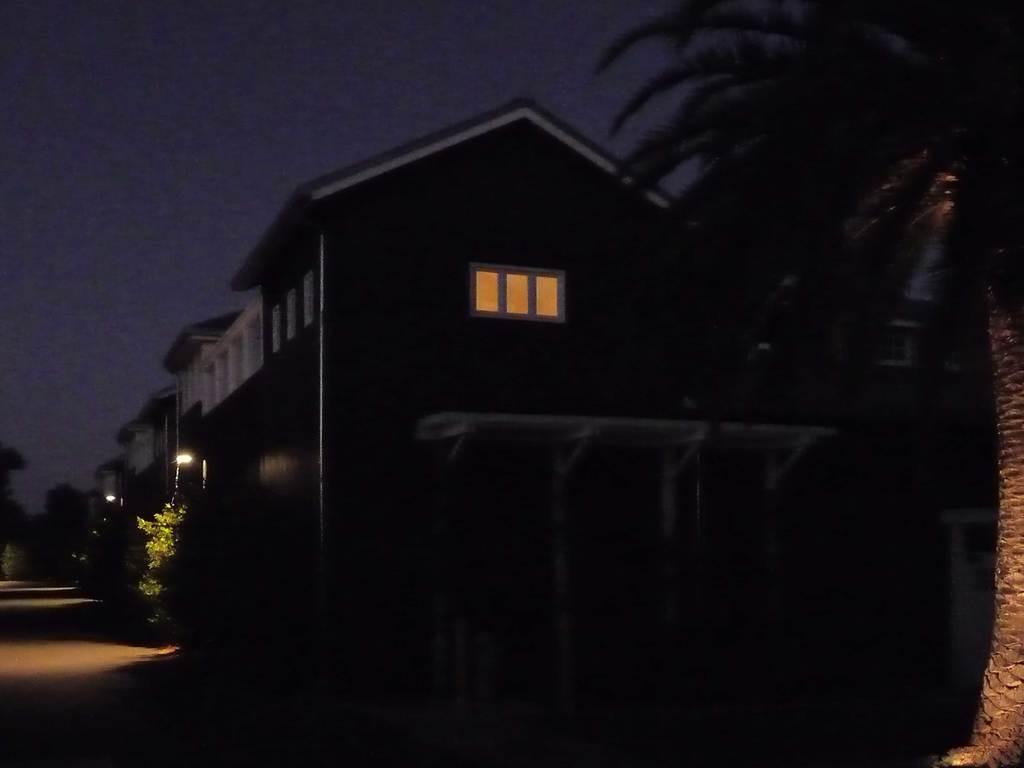How would you summarize this image in a sentence or two? On the right side of the image there is a tree. On the left side of the image there is a road. There are buildings, plants, lights. In the background of the image there are trees and sky. 